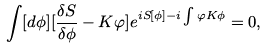<formula> <loc_0><loc_0><loc_500><loc_500>\int [ d \phi ] [ \frac { \delta S } { \delta \phi } - K \varphi ] e ^ { i S [ \phi ] - i \int \varphi K \phi } = 0 ,</formula> 